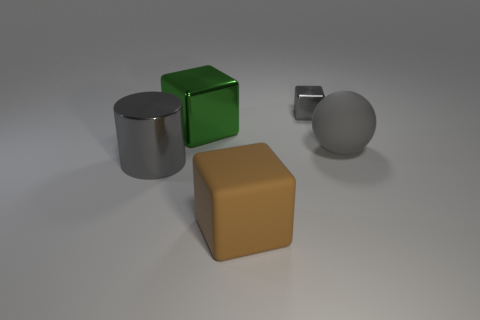Does the tiny thing have the same material as the big green block?
Offer a very short reply. Yes. What number of objects are either shiny cubes to the left of the big brown matte object or shiny objects that are left of the brown rubber thing?
Provide a succinct answer. 2. There is a tiny object that is the same shape as the large brown object; what color is it?
Give a very brief answer. Gray. How many other metal things have the same color as the tiny thing?
Offer a terse response. 1. Is the color of the tiny cube the same as the large ball?
Offer a terse response. Yes. What number of objects are gray objects in front of the gray metal block or large brown objects?
Provide a succinct answer. 3. There is a cube that is in front of the large metal object that is behind the large gray object on the right side of the brown block; what is its color?
Make the answer very short. Brown. The large cylinder that is the same material as the small gray thing is what color?
Your answer should be very brief. Gray. How many other large balls are the same material as the big gray ball?
Provide a succinct answer. 0. Is the size of the metallic cube in front of the gray metallic cube the same as the matte ball?
Provide a succinct answer. Yes. 